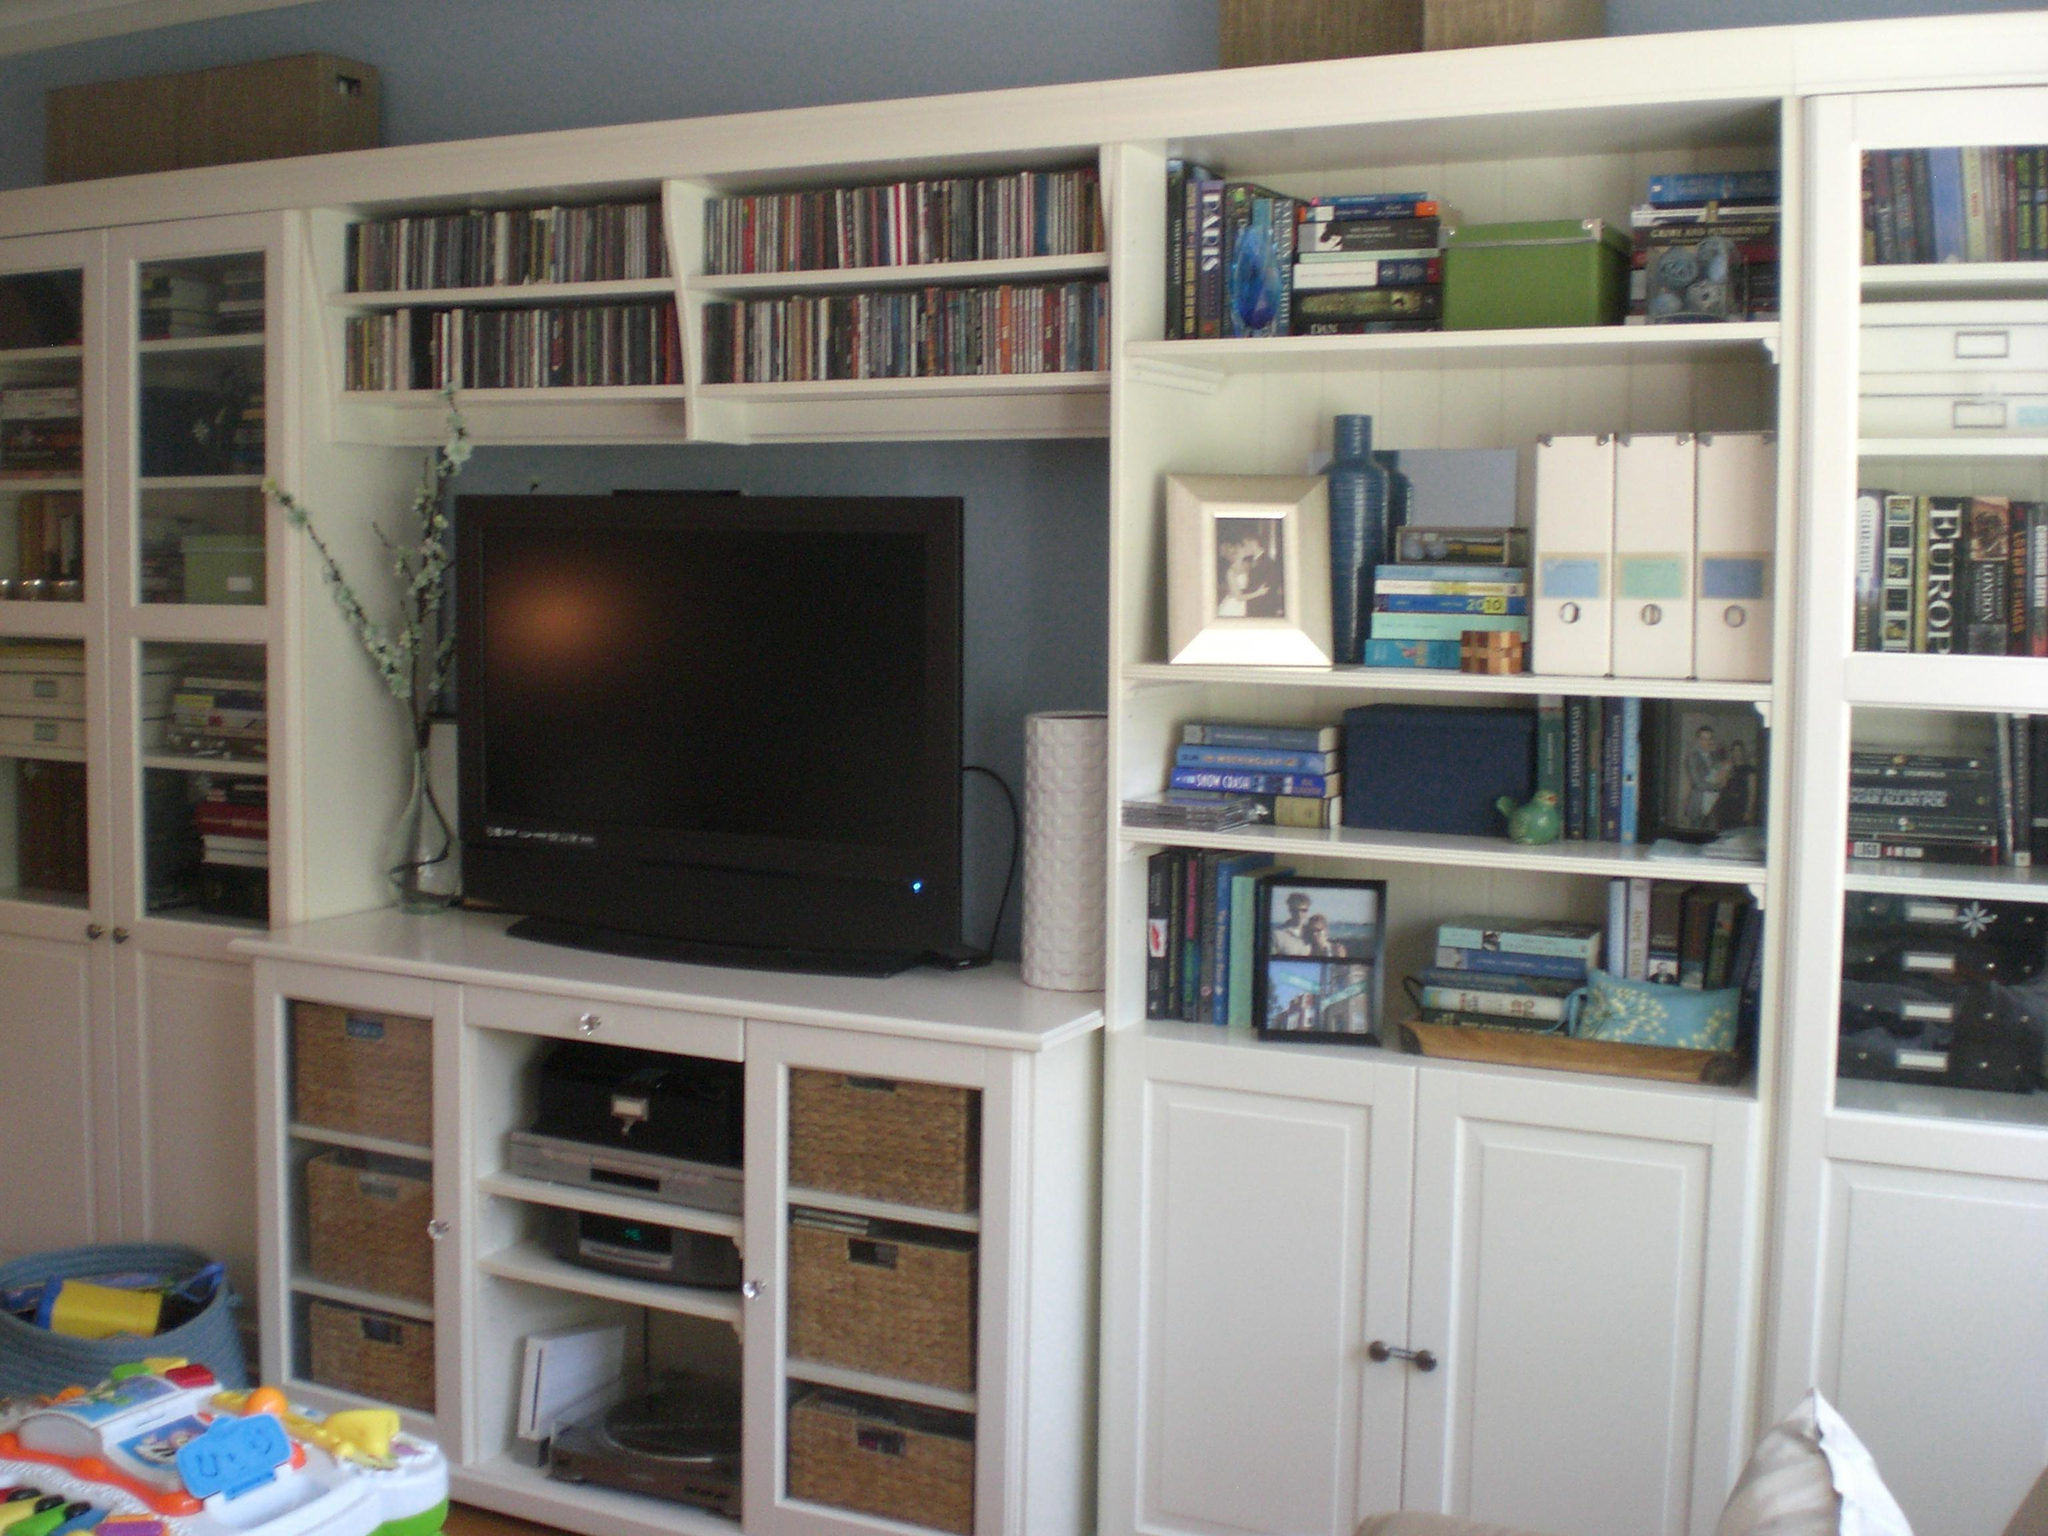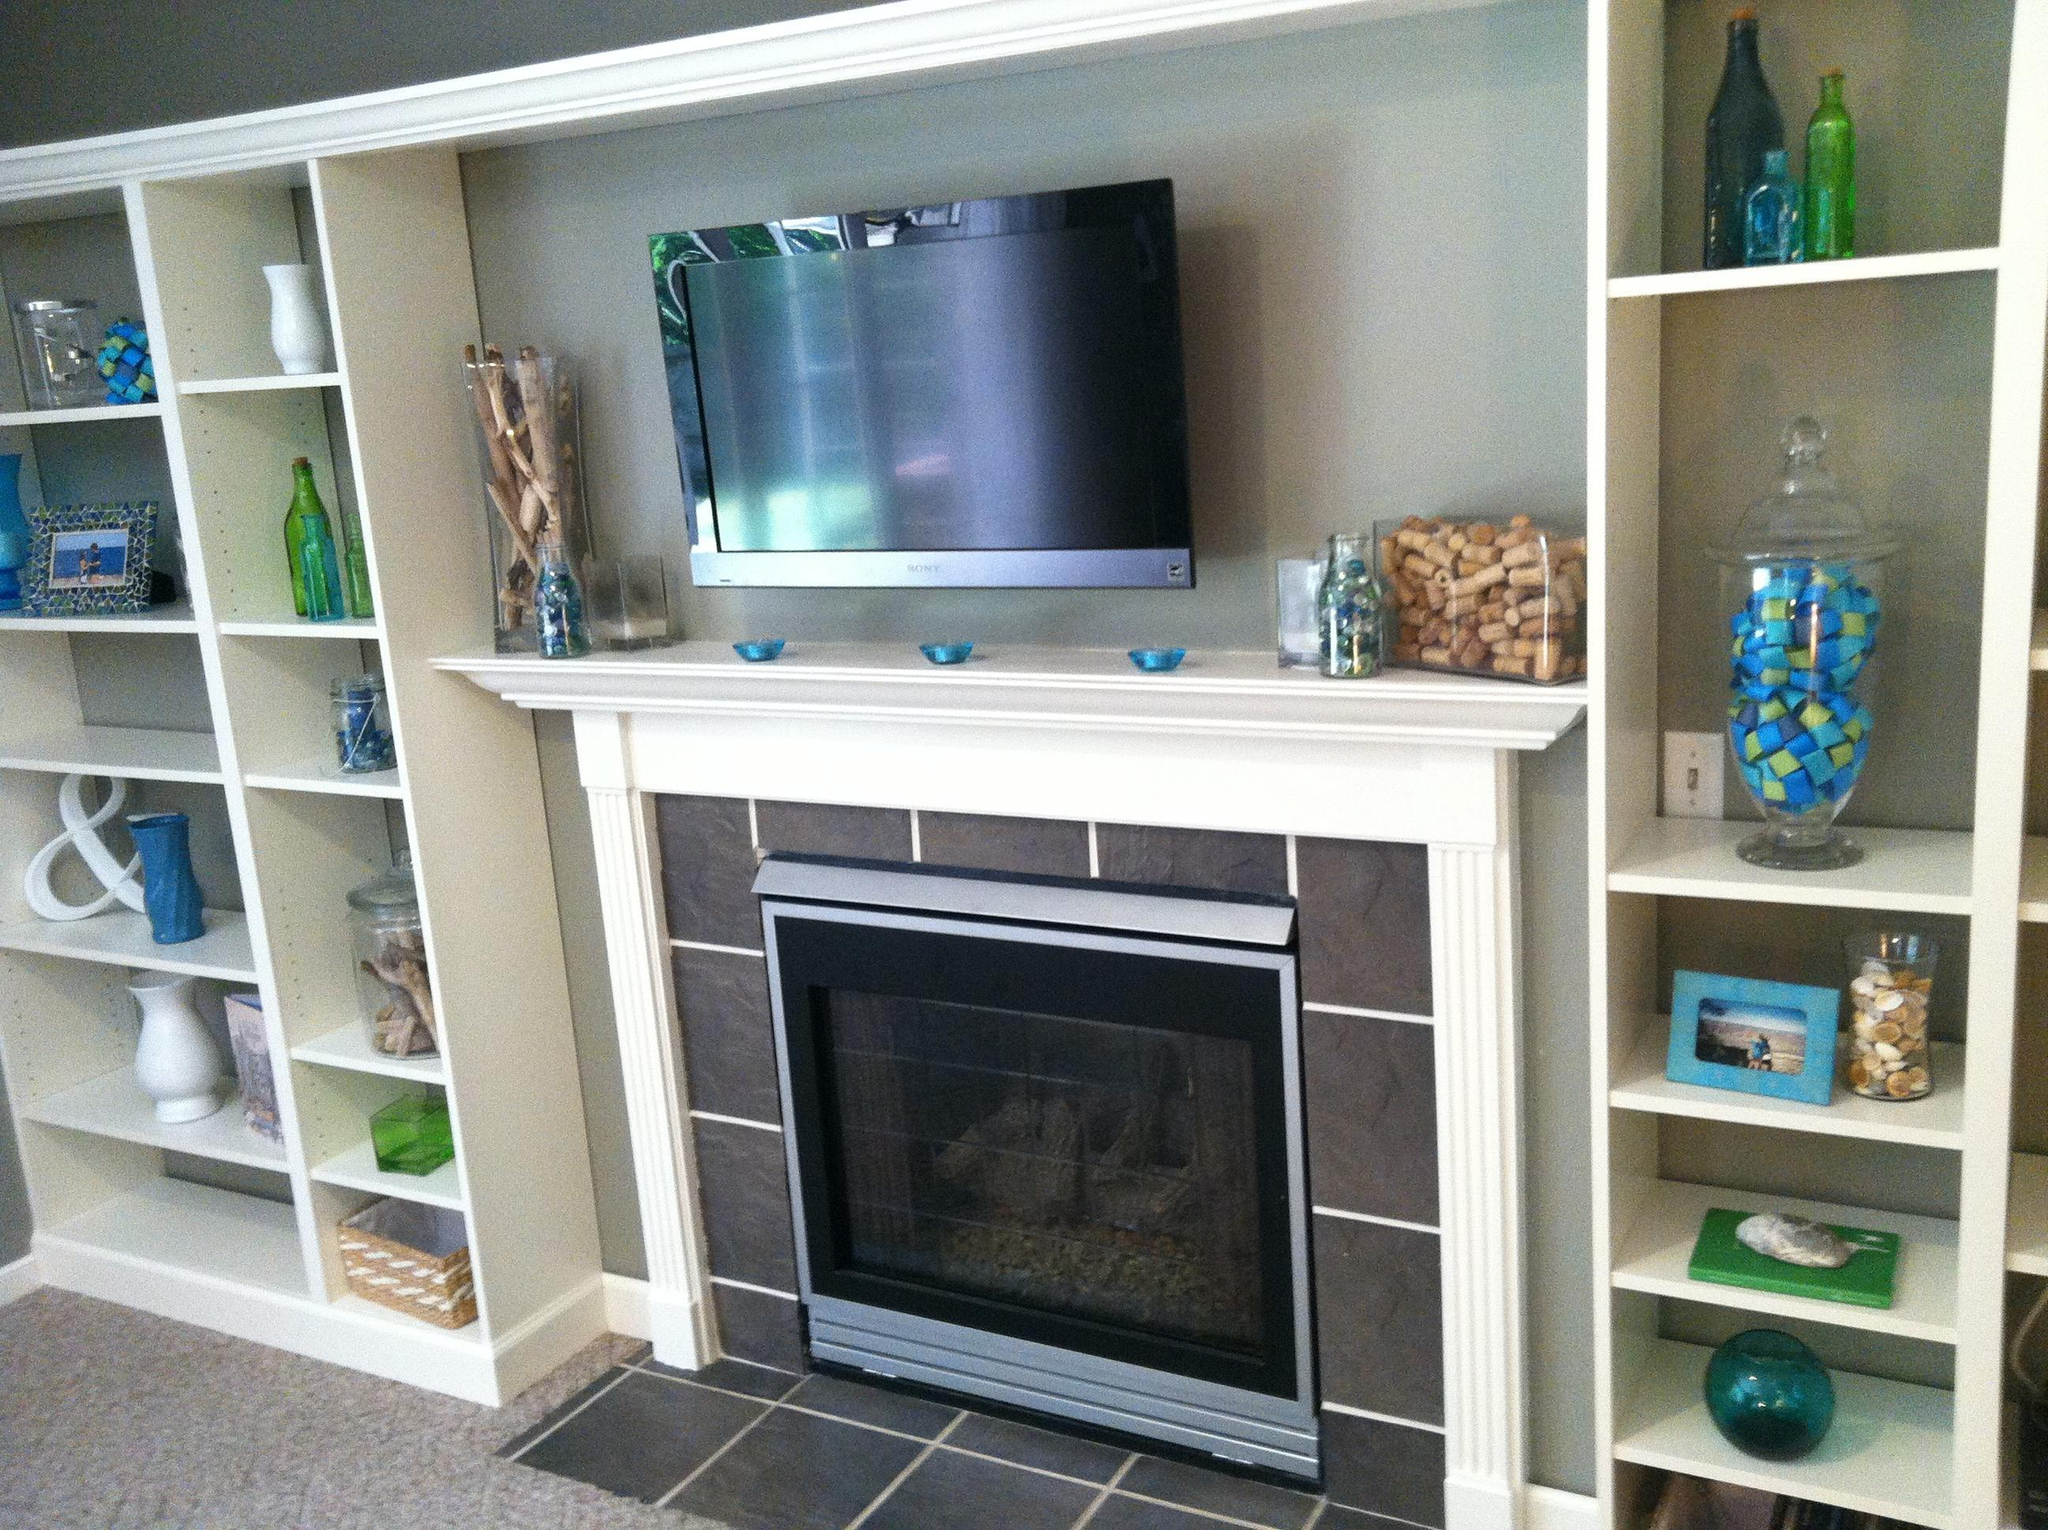The first image is the image on the left, the second image is the image on the right. Examine the images to the left and right. Is the description "An image features a woman in jeans in front of a white bookcase." accurate? Answer yes or no. No. The first image is the image on the left, the second image is the image on the right. For the images shown, is this caption "The white bookshelves in one image are floor to ceiling and have a sliding ladder with visible track to allow access to upper shelves." true? Answer yes or no. No. 